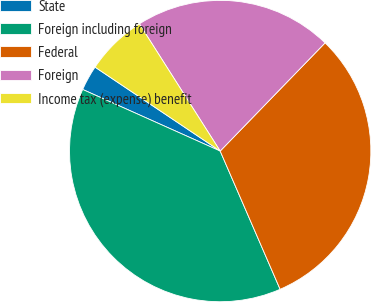<chart> <loc_0><loc_0><loc_500><loc_500><pie_chart><fcel>State<fcel>Foreign including foreign<fcel>Federal<fcel>Foreign<fcel>Income tax (expense) benefit<nl><fcel>2.7%<fcel>38.21%<fcel>31.23%<fcel>21.26%<fcel>6.59%<nl></chart> 